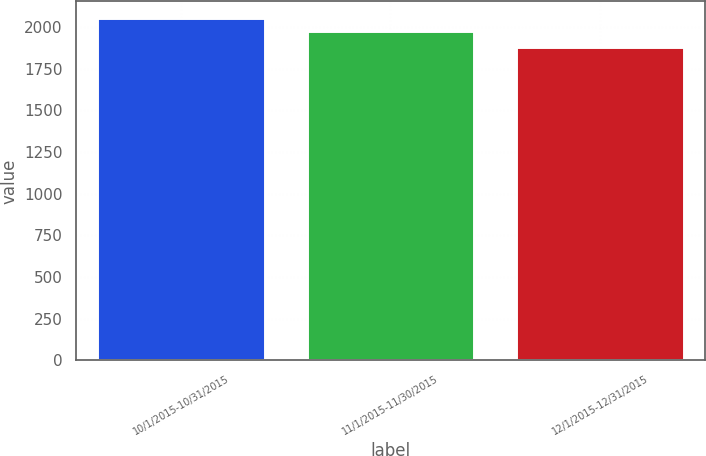<chart> <loc_0><loc_0><loc_500><loc_500><bar_chart><fcel>10/1/2015-10/31/2015<fcel>11/1/2015-11/30/2015<fcel>12/1/2015-12/31/2015<nl><fcel>2052<fcel>1974<fcel>1883<nl></chart> 